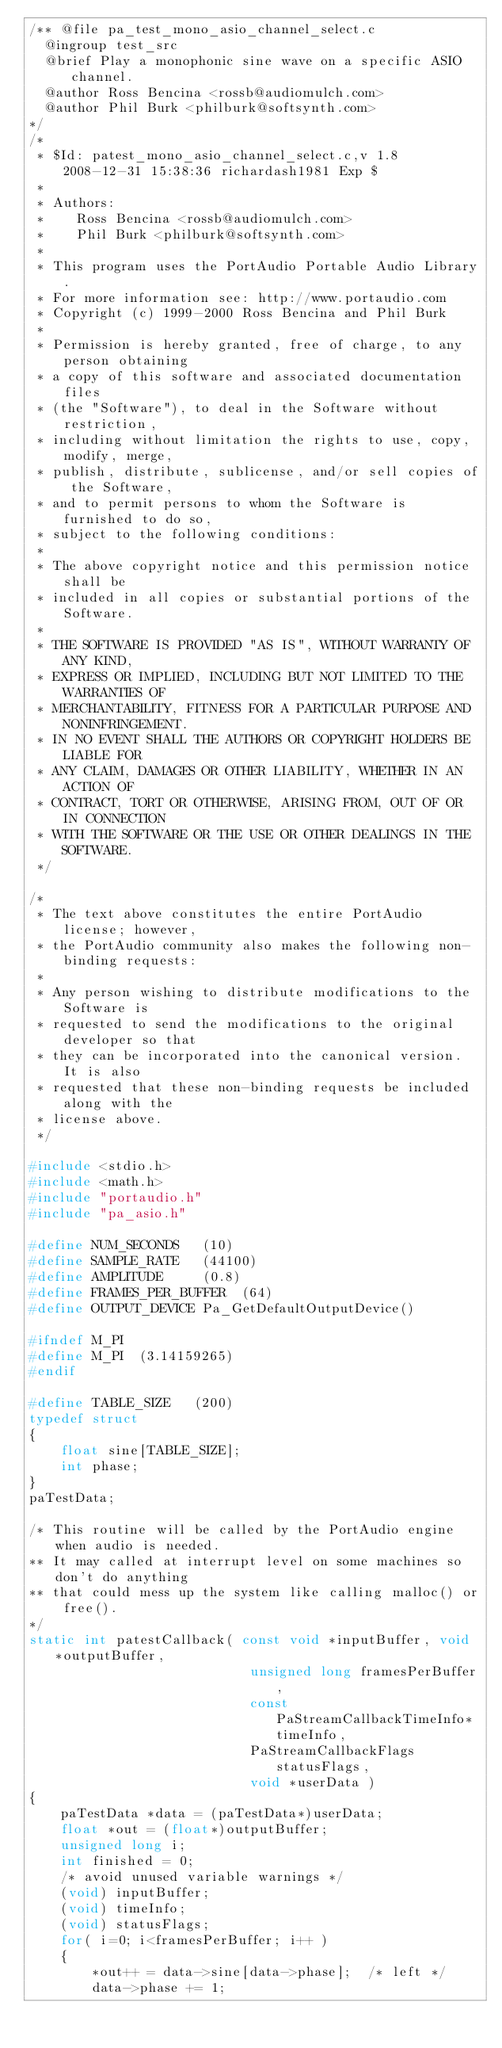<code> <loc_0><loc_0><loc_500><loc_500><_C_>/** @file pa_test_mono_asio_channel_select.c
	@ingroup test_src
	@brief Play a monophonic sine wave on a specific ASIO channel.
	@author Ross Bencina <rossb@audiomulch.com>
	@author Phil Burk <philburk@softsynth.com>
*/
/*
 * $Id: patest_mono_asio_channel_select.c,v 1.8 2008-12-31 15:38:36 richardash1981 Exp $
 *
 * Authors:
 *    Ross Bencina <rossb@audiomulch.com>
 *    Phil Burk <philburk@softsynth.com>
 *
 * This program uses the PortAudio Portable Audio Library.
 * For more information see: http://www.portaudio.com
 * Copyright (c) 1999-2000 Ross Bencina and Phil Burk
 *
 * Permission is hereby granted, free of charge, to any person obtaining
 * a copy of this software and associated documentation files
 * (the "Software"), to deal in the Software without restriction,
 * including without limitation the rights to use, copy, modify, merge,
 * publish, distribute, sublicense, and/or sell copies of the Software,
 * and to permit persons to whom the Software is furnished to do so,
 * subject to the following conditions:
 *
 * The above copyright notice and this permission notice shall be
 * included in all copies or substantial portions of the Software.
 *
 * THE SOFTWARE IS PROVIDED "AS IS", WITHOUT WARRANTY OF ANY KIND,
 * EXPRESS OR IMPLIED, INCLUDING BUT NOT LIMITED TO THE WARRANTIES OF
 * MERCHANTABILITY, FITNESS FOR A PARTICULAR PURPOSE AND NONINFRINGEMENT.
 * IN NO EVENT SHALL THE AUTHORS OR COPYRIGHT HOLDERS BE LIABLE FOR
 * ANY CLAIM, DAMAGES OR OTHER LIABILITY, WHETHER IN AN ACTION OF
 * CONTRACT, TORT OR OTHERWISE, ARISING FROM, OUT OF OR IN CONNECTION
 * WITH THE SOFTWARE OR THE USE OR OTHER DEALINGS IN THE SOFTWARE.
 */

/*
 * The text above constitutes the entire PortAudio license; however, 
 * the PortAudio community also makes the following non-binding requests:
 *
 * Any person wishing to distribute modifications to the Software is
 * requested to send the modifications to the original developer so that
 * they can be incorporated into the canonical version. It is also 
 * requested that these non-binding requests be included along with the 
 * license above.
 */

#include <stdio.h>
#include <math.h>
#include "portaudio.h"
#include "pa_asio.h"

#define NUM_SECONDS   (10)
#define SAMPLE_RATE   (44100)
#define AMPLITUDE     (0.8)
#define FRAMES_PER_BUFFER  (64)
#define OUTPUT_DEVICE Pa_GetDefaultOutputDevice()

#ifndef M_PI
#define M_PI  (3.14159265)
#endif

#define TABLE_SIZE   (200)
typedef struct
{
    float sine[TABLE_SIZE];
    int phase;
}
paTestData;

/* This routine will be called by the PortAudio engine when audio is needed.
** It may called at interrupt level on some machines so don't do anything
** that could mess up the system like calling malloc() or free().
*/
static int patestCallback( const void *inputBuffer, void *outputBuffer,
                            unsigned long framesPerBuffer,
                            const PaStreamCallbackTimeInfo* timeInfo,
                            PaStreamCallbackFlags statusFlags,
                            void *userData )
{
    paTestData *data = (paTestData*)userData;
    float *out = (float*)outputBuffer;
    unsigned long i;
    int finished = 0;
    /* avoid unused variable warnings */
    (void) inputBuffer;
    (void) timeInfo;
    (void) statusFlags;
    for( i=0; i<framesPerBuffer; i++ )
    {
        *out++ = data->sine[data->phase];  /* left */
        data->phase += 1;</code> 